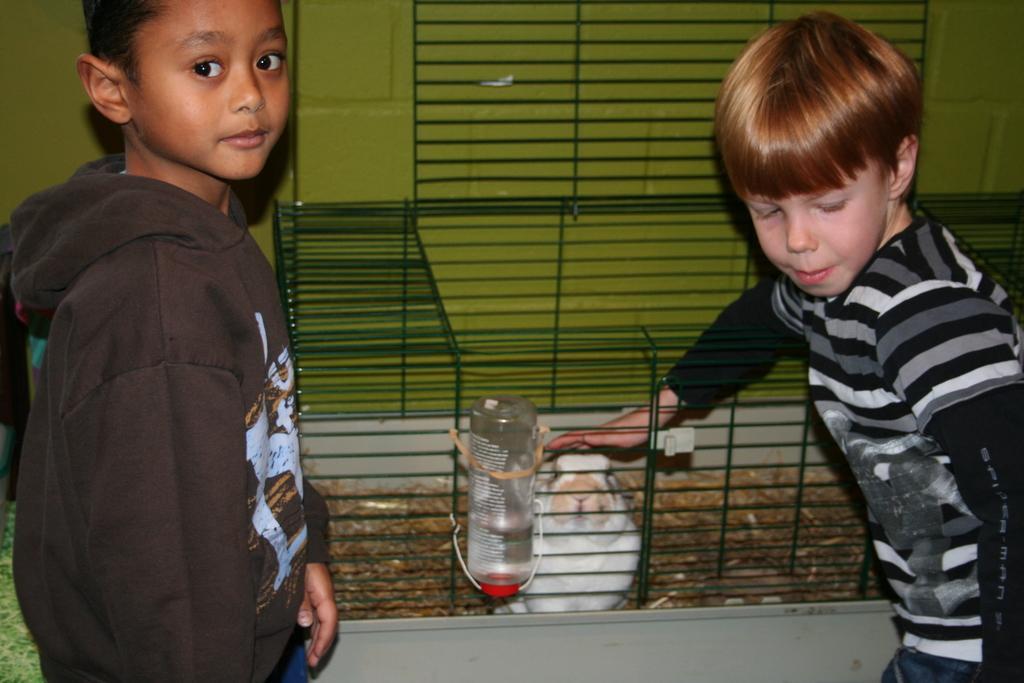Can you describe this image briefly? In this image, we can see two people and one of them is wearing a sweater and in the background, there is a cage and we can see an animal and a bottle and there is a wall. 